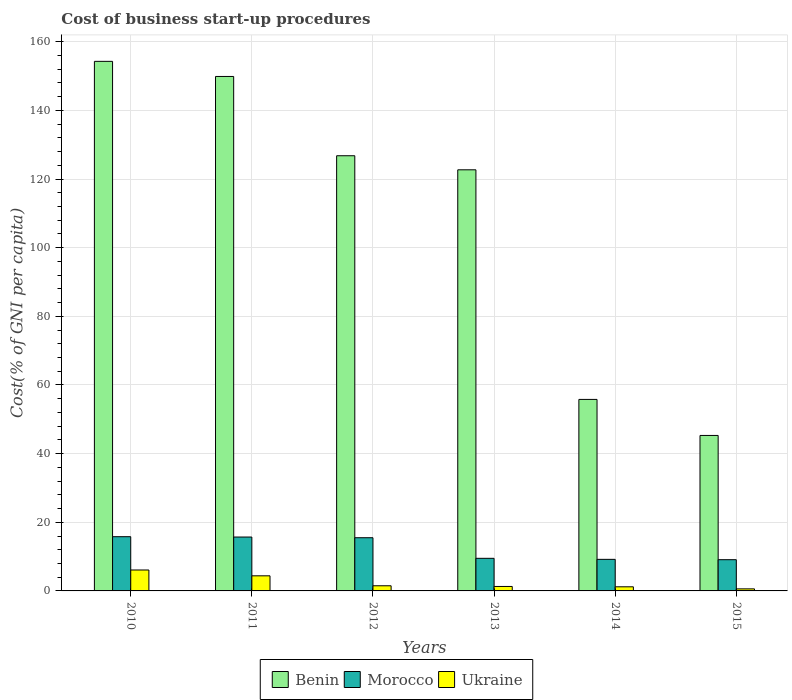Are the number of bars per tick equal to the number of legend labels?
Offer a very short reply. Yes. How many bars are there on the 5th tick from the right?
Provide a short and direct response. 3. What is the label of the 6th group of bars from the left?
Your response must be concise. 2015. In how many cases, is the number of bars for a given year not equal to the number of legend labels?
Offer a terse response. 0. What is the cost of business start-up procedures in Ukraine in 2010?
Ensure brevity in your answer.  6.1. Across all years, what is the maximum cost of business start-up procedures in Benin?
Provide a short and direct response. 154.3. Across all years, what is the minimum cost of business start-up procedures in Morocco?
Give a very brief answer. 9.1. In which year was the cost of business start-up procedures in Benin maximum?
Your response must be concise. 2010. In which year was the cost of business start-up procedures in Morocco minimum?
Provide a succinct answer. 2015. What is the total cost of business start-up procedures in Ukraine in the graph?
Offer a very short reply. 15.1. What is the difference between the cost of business start-up procedures in Benin in 2012 and that in 2014?
Provide a succinct answer. 71. What is the difference between the cost of business start-up procedures in Benin in 2014 and the cost of business start-up procedures in Morocco in 2012?
Your answer should be very brief. 40.3. What is the average cost of business start-up procedures in Benin per year?
Keep it short and to the point. 109.13. In the year 2015, what is the difference between the cost of business start-up procedures in Ukraine and cost of business start-up procedures in Benin?
Provide a short and direct response. -44.7. What is the ratio of the cost of business start-up procedures in Morocco in 2011 to that in 2012?
Provide a succinct answer. 1.01. Is the cost of business start-up procedures in Benin in 2010 less than that in 2012?
Offer a very short reply. No. What is the difference between the highest and the second highest cost of business start-up procedures in Morocco?
Offer a terse response. 0.1. In how many years, is the cost of business start-up procedures in Benin greater than the average cost of business start-up procedures in Benin taken over all years?
Your answer should be very brief. 4. What does the 3rd bar from the left in 2013 represents?
Your answer should be very brief. Ukraine. What does the 2nd bar from the right in 2015 represents?
Provide a succinct answer. Morocco. How many bars are there?
Provide a short and direct response. 18. Where does the legend appear in the graph?
Give a very brief answer. Bottom center. What is the title of the graph?
Give a very brief answer. Cost of business start-up procedures. What is the label or title of the Y-axis?
Your response must be concise. Cost(% of GNI per capita). What is the Cost(% of GNI per capita) of Benin in 2010?
Ensure brevity in your answer.  154.3. What is the Cost(% of GNI per capita) in Ukraine in 2010?
Provide a succinct answer. 6.1. What is the Cost(% of GNI per capita) of Benin in 2011?
Keep it short and to the point. 149.9. What is the Cost(% of GNI per capita) in Ukraine in 2011?
Make the answer very short. 4.4. What is the Cost(% of GNI per capita) of Benin in 2012?
Offer a very short reply. 126.8. What is the Cost(% of GNI per capita) in Ukraine in 2012?
Your response must be concise. 1.5. What is the Cost(% of GNI per capita) of Benin in 2013?
Provide a short and direct response. 122.7. What is the Cost(% of GNI per capita) of Morocco in 2013?
Offer a terse response. 9.5. What is the Cost(% of GNI per capita) in Ukraine in 2013?
Your answer should be compact. 1.3. What is the Cost(% of GNI per capita) in Benin in 2014?
Provide a short and direct response. 55.8. What is the Cost(% of GNI per capita) in Morocco in 2014?
Offer a very short reply. 9.2. What is the Cost(% of GNI per capita) of Ukraine in 2014?
Provide a short and direct response. 1.2. What is the Cost(% of GNI per capita) of Benin in 2015?
Give a very brief answer. 45.3. What is the Cost(% of GNI per capita) of Morocco in 2015?
Ensure brevity in your answer.  9.1. What is the Cost(% of GNI per capita) in Ukraine in 2015?
Your answer should be very brief. 0.6. Across all years, what is the maximum Cost(% of GNI per capita) in Benin?
Offer a terse response. 154.3. Across all years, what is the maximum Cost(% of GNI per capita) of Ukraine?
Provide a succinct answer. 6.1. Across all years, what is the minimum Cost(% of GNI per capita) in Benin?
Your answer should be very brief. 45.3. Across all years, what is the minimum Cost(% of GNI per capita) in Morocco?
Your answer should be very brief. 9.1. Across all years, what is the minimum Cost(% of GNI per capita) in Ukraine?
Offer a very short reply. 0.6. What is the total Cost(% of GNI per capita) of Benin in the graph?
Provide a short and direct response. 654.8. What is the total Cost(% of GNI per capita) of Morocco in the graph?
Offer a terse response. 74.8. What is the total Cost(% of GNI per capita) in Ukraine in the graph?
Provide a short and direct response. 15.1. What is the difference between the Cost(% of GNI per capita) in Benin in 2010 and that in 2011?
Your response must be concise. 4.4. What is the difference between the Cost(% of GNI per capita) of Ukraine in 2010 and that in 2011?
Your response must be concise. 1.7. What is the difference between the Cost(% of GNI per capita) in Benin in 2010 and that in 2012?
Provide a short and direct response. 27.5. What is the difference between the Cost(% of GNI per capita) of Morocco in 2010 and that in 2012?
Provide a short and direct response. 0.3. What is the difference between the Cost(% of GNI per capita) in Ukraine in 2010 and that in 2012?
Offer a terse response. 4.6. What is the difference between the Cost(% of GNI per capita) in Benin in 2010 and that in 2013?
Offer a terse response. 31.6. What is the difference between the Cost(% of GNI per capita) of Benin in 2010 and that in 2014?
Make the answer very short. 98.5. What is the difference between the Cost(% of GNI per capita) in Morocco in 2010 and that in 2014?
Your answer should be compact. 6.6. What is the difference between the Cost(% of GNI per capita) in Ukraine in 2010 and that in 2014?
Your answer should be compact. 4.9. What is the difference between the Cost(% of GNI per capita) of Benin in 2010 and that in 2015?
Offer a very short reply. 109. What is the difference between the Cost(% of GNI per capita) of Benin in 2011 and that in 2012?
Your answer should be very brief. 23.1. What is the difference between the Cost(% of GNI per capita) of Morocco in 2011 and that in 2012?
Ensure brevity in your answer.  0.2. What is the difference between the Cost(% of GNI per capita) of Benin in 2011 and that in 2013?
Provide a succinct answer. 27.2. What is the difference between the Cost(% of GNI per capita) in Benin in 2011 and that in 2014?
Give a very brief answer. 94.1. What is the difference between the Cost(% of GNI per capita) of Benin in 2011 and that in 2015?
Give a very brief answer. 104.6. What is the difference between the Cost(% of GNI per capita) in Morocco in 2011 and that in 2015?
Make the answer very short. 6.6. What is the difference between the Cost(% of GNI per capita) of Ukraine in 2011 and that in 2015?
Ensure brevity in your answer.  3.8. What is the difference between the Cost(% of GNI per capita) in Benin in 2012 and that in 2013?
Offer a terse response. 4.1. What is the difference between the Cost(% of GNI per capita) in Morocco in 2012 and that in 2013?
Your answer should be very brief. 6. What is the difference between the Cost(% of GNI per capita) of Benin in 2012 and that in 2015?
Provide a short and direct response. 81.5. What is the difference between the Cost(% of GNI per capita) of Benin in 2013 and that in 2014?
Your answer should be very brief. 66.9. What is the difference between the Cost(% of GNI per capita) in Morocco in 2013 and that in 2014?
Offer a terse response. 0.3. What is the difference between the Cost(% of GNI per capita) in Benin in 2013 and that in 2015?
Your response must be concise. 77.4. What is the difference between the Cost(% of GNI per capita) of Benin in 2014 and that in 2015?
Ensure brevity in your answer.  10.5. What is the difference between the Cost(% of GNI per capita) in Morocco in 2014 and that in 2015?
Keep it short and to the point. 0.1. What is the difference between the Cost(% of GNI per capita) in Ukraine in 2014 and that in 2015?
Your answer should be compact. 0.6. What is the difference between the Cost(% of GNI per capita) of Benin in 2010 and the Cost(% of GNI per capita) of Morocco in 2011?
Give a very brief answer. 138.6. What is the difference between the Cost(% of GNI per capita) of Benin in 2010 and the Cost(% of GNI per capita) of Ukraine in 2011?
Ensure brevity in your answer.  149.9. What is the difference between the Cost(% of GNI per capita) in Morocco in 2010 and the Cost(% of GNI per capita) in Ukraine in 2011?
Offer a very short reply. 11.4. What is the difference between the Cost(% of GNI per capita) in Benin in 2010 and the Cost(% of GNI per capita) in Morocco in 2012?
Give a very brief answer. 138.8. What is the difference between the Cost(% of GNI per capita) of Benin in 2010 and the Cost(% of GNI per capita) of Ukraine in 2012?
Your answer should be very brief. 152.8. What is the difference between the Cost(% of GNI per capita) of Benin in 2010 and the Cost(% of GNI per capita) of Morocco in 2013?
Offer a very short reply. 144.8. What is the difference between the Cost(% of GNI per capita) in Benin in 2010 and the Cost(% of GNI per capita) in Ukraine in 2013?
Your response must be concise. 153. What is the difference between the Cost(% of GNI per capita) in Morocco in 2010 and the Cost(% of GNI per capita) in Ukraine in 2013?
Provide a succinct answer. 14.5. What is the difference between the Cost(% of GNI per capita) of Benin in 2010 and the Cost(% of GNI per capita) of Morocco in 2014?
Make the answer very short. 145.1. What is the difference between the Cost(% of GNI per capita) in Benin in 2010 and the Cost(% of GNI per capita) in Ukraine in 2014?
Your answer should be compact. 153.1. What is the difference between the Cost(% of GNI per capita) in Morocco in 2010 and the Cost(% of GNI per capita) in Ukraine in 2014?
Give a very brief answer. 14.6. What is the difference between the Cost(% of GNI per capita) of Benin in 2010 and the Cost(% of GNI per capita) of Morocco in 2015?
Make the answer very short. 145.2. What is the difference between the Cost(% of GNI per capita) in Benin in 2010 and the Cost(% of GNI per capita) in Ukraine in 2015?
Your answer should be very brief. 153.7. What is the difference between the Cost(% of GNI per capita) of Benin in 2011 and the Cost(% of GNI per capita) of Morocco in 2012?
Ensure brevity in your answer.  134.4. What is the difference between the Cost(% of GNI per capita) of Benin in 2011 and the Cost(% of GNI per capita) of Ukraine in 2012?
Give a very brief answer. 148.4. What is the difference between the Cost(% of GNI per capita) in Benin in 2011 and the Cost(% of GNI per capita) in Morocco in 2013?
Your answer should be very brief. 140.4. What is the difference between the Cost(% of GNI per capita) in Benin in 2011 and the Cost(% of GNI per capita) in Ukraine in 2013?
Your answer should be compact. 148.6. What is the difference between the Cost(% of GNI per capita) of Morocco in 2011 and the Cost(% of GNI per capita) of Ukraine in 2013?
Keep it short and to the point. 14.4. What is the difference between the Cost(% of GNI per capita) in Benin in 2011 and the Cost(% of GNI per capita) in Morocco in 2014?
Your response must be concise. 140.7. What is the difference between the Cost(% of GNI per capita) in Benin in 2011 and the Cost(% of GNI per capita) in Ukraine in 2014?
Provide a succinct answer. 148.7. What is the difference between the Cost(% of GNI per capita) of Morocco in 2011 and the Cost(% of GNI per capita) of Ukraine in 2014?
Your answer should be very brief. 14.5. What is the difference between the Cost(% of GNI per capita) of Benin in 2011 and the Cost(% of GNI per capita) of Morocco in 2015?
Your response must be concise. 140.8. What is the difference between the Cost(% of GNI per capita) in Benin in 2011 and the Cost(% of GNI per capita) in Ukraine in 2015?
Offer a very short reply. 149.3. What is the difference between the Cost(% of GNI per capita) of Benin in 2012 and the Cost(% of GNI per capita) of Morocco in 2013?
Offer a terse response. 117.3. What is the difference between the Cost(% of GNI per capita) in Benin in 2012 and the Cost(% of GNI per capita) in Ukraine in 2013?
Make the answer very short. 125.5. What is the difference between the Cost(% of GNI per capita) of Benin in 2012 and the Cost(% of GNI per capita) of Morocco in 2014?
Your answer should be very brief. 117.6. What is the difference between the Cost(% of GNI per capita) in Benin in 2012 and the Cost(% of GNI per capita) in Ukraine in 2014?
Provide a short and direct response. 125.6. What is the difference between the Cost(% of GNI per capita) in Benin in 2012 and the Cost(% of GNI per capita) in Morocco in 2015?
Offer a very short reply. 117.7. What is the difference between the Cost(% of GNI per capita) in Benin in 2012 and the Cost(% of GNI per capita) in Ukraine in 2015?
Give a very brief answer. 126.2. What is the difference between the Cost(% of GNI per capita) in Morocco in 2012 and the Cost(% of GNI per capita) in Ukraine in 2015?
Your answer should be very brief. 14.9. What is the difference between the Cost(% of GNI per capita) in Benin in 2013 and the Cost(% of GNI per capita) in Morocco in 2014?
Make the answer very short. 113.5. What is the difference between the Cost(% of GNI per capita) of Benin in 2013 and the Cost(% of GNI per capita) of Ukraine in 2014?
Provide a succinct answer. 121.5. What is the difference between the Cost(% of GNI per capita) in Morocco in 2013 and the Cost(% of GNI per capita) in Ukraine in 2014?
Ensure brevity in your answer.  8.3. What is the difference between the Cost(% of GNI per capita) of Benin in 2013 and the Cost(% of GNI per capita) of Morocco in 2015?
Offer a very short reply. 113.6. What is the difference between the Cost(% of GNI per capita) of Benin in 2013 and the Cost(% of GNI per capita) of Ukraine in 2015?
Your answer should be compact. 122.1. What is the difference between the Cost(% of GNI per capita) in Benin in 2014 and the Cost(% of GNI per capita) in Morocco in 2015?
Your answer should be compact. 46.7. What is the difference between the Cost(% of GNI per capita) of Benin in 2014 and the Cost(% of GNI per capita) of Ukraine in 2015?
Offer a terse response. 55.2. What is the average Cost(% of GNI per capita) in Benin per year?
Your answer should be very brief. 109.13. What is the average Cost(% of GNI per capita) of Morocco per year?
Your answer should be compact. 12.47. What is the average Cost(% of GNI per capita) of Ukraine per year?
Your answer should be very brief. 2.52. In the year 2010, what is the difference between the Cost(% of GNI per capita) of Benin and Cost(% of GNI per capita) of Morocco?
Make the answer very short. 138.5. In the year 2010, what is the difference between the Cost(% of GNI per capita) in Benin and Cost(% of GNI per capita) in Ukraine?
Provide a succinct answer. 148.2. In the year 2011, what is the difference between the Cost(% of GNI per capita) in Benin and Cost(% of GNI per capita) in Morocco?
Provide a short and direct response. 134.2. In the year 2011, what is the difference between the Cost(% of GNI per capita) in Benin and Cost(% of GNI per capita) in Ukraine?
Give a very brief answer. 145.5. In the year 2011, what is the difference between the Cost(% of GNI per capita) of Morocco and Cost(% of GNI per capita) of Ukraine?
Ensure brevity in your answer.  11.3. In the year 2012, what is the difference between the Cost(% of GNI per capita) of Benin and Cost(% of GNI per capita) of Morocco?
Your answer should be very brief. 111.3. In the year 2012, what is the difference between the Cost(% of GNI per capita) in Benin and Cost(% of GNI per capita) in Ukraine?
Provide a succinct answer. 125.3. In the year 2013, what is the difference between the Cost(% of GNI per capita) in Benin and Cost(% of GNI per capita) in Morocco?
Provide a short and direct response. 113.2. In the year 2013, what is the difference between the Cost(% of GNI per capita) in Benin and Cost(% of GNI per capita) in Ukraine?
Your answer should be compact. 121.4. In the year 2014, what is the difference between the Cost(% of GNI per capita) of Benin and Cost(% of GNI per capita) of Morocco?
Provide a succinct answer. 46.6. In the year 2014, what is the difference between the Cost(% of GNI per capita) of Benin and Cost(% of GNI per capita) of Ukraine?
Keep it short and to the point. 54.6. In the year 2014, what is the difference between the Cost(% of GNI per capita) of Morocco and Cost(% of GNI per capita) of Ukraine?
Provide a short and direct response. 8. In the year 2015, what is the difference between the Cost(% of GNI per capita) in Benin and Cost(% of GNI per capita) in Morocco?
Make the answer very short. 36.2. In the year 2015, what is the difference between the Cost(% of GNI per capita) in Benin and Cost(% of GNI per capita) in Ukraine?
Make the answer very short. 44.7. What is the ratio of the Cost(% of GNI per capita) of Benin in 2010 to that in 2011?
Make the answer very short. 1.03. What is the ratio of the Cost(% of GNI per capita) in Morocco in 2010 to that in 2011?
Provide a succinct answer. 1.01. What is the ratio of the Cost(% of GNI per capita) in Ukraine in 2010 to that in 2011?
Your response must be concise. 1.39. What is the ratio of the Cost(% of GNI per capita) of Benin in 2010 to that in 2012?
Keep it short and to the point. 1.22. What is the ratio of the Cost(% of GNI per capita) of Morocco in 2010 to that in 2012?
Provide a short and direct response. 1.02. What is the ratio of the Cost(% of GNI per capita) in Ukraine in 2010 to that in 2012?
Your answer should be very brief. 4.07. What is the ratio of the Cost(% of GNI per capita) in Benin in 2010 to that in 2013?
Give a very brief answer. 1.26. What is the ratio of the Cost(% of GNI per capita) in Morocco in 2010 to that in 2013?
Provide a short and direct response. 1.66. What is the ratio of the Cost(% of GNI per capita) of Ukraine in 2010 to that in 2013?
Provide a short and direct response. 4.69. What is the ratio of the Cost(% of GNI per capita) in Benin in 2010 to that in 2014?
Make the answer very short. 2.77. What is the ratio of the Cost(% of GNI per capita) of Morocco in 2010 to that in 2014?
Ensure brevity in your answer.  1.72. What is the ratio of the Cost(% of GNI per capita) of Ukraine in 2010 to that in 2014?
Provide a short and direct response. 5.08. What is the ratio of the Cost(% of GNI per capita) of Benin in 2010 to that in 2015?
Provide a short and direct response. 3.41. What is the ratio of the Cost(% of GNI per capita) of Morocco in 2010 to that in 2015?
Make the answer very short. 1.74. What is the ratio of the Cost(% of GNI per capita) of Ukraine in 2010 to that in 2015?
Provide a short and direct response. 10.17. What is the ratio of the Cost(% of GNI per capita) of Benin in 2011 to that in 2012?
Provide a short and direct response. 1.18. What is the ratio of the Cost(% of GNI per capita) in Morocco in 2011 to that in 2012?
Your answer should be very brief. 1.01. What is the ratio of the Cost(% of GNI per capita) in Ukraine in 2011 to that in 2012?
Your answer should be very brief. 2.93. What is the ratio of the Cost(% of GNI per capita) of Benin in 2011 to that in 2013?
Your response must be concise. 1.22. What is the ratio of the Cost(% of GNI per capita) of Morocco in 2011 to that in 2013?
Provide a succinct answer. 1.65. What is the ratio of the Cost(% of GNI per capita) in Ukraine in 2011 to that in 2013?
Offer a very short reply. 3.38. What is the ratio of the Cost(% of GNI per capita) in Benin in 2011 to that in 2014?
Provide a short and direct response. 2.69. What is the ratio of the Cost(% of GNI per capita) in Morocco in 2011 to that in 2014?
Give a very brief answer. 1.71. What is the ratio of the Cost(% of GNI per capita) in Ukraine in 2011 to that in 2014?
Ensure brevity in your answer.  3.67. What is the ratio of the Cost(% of GNI per capita) of Benin in 2011 to that in 2015?
Your response must be concise. 3.31. What is the ratio of the Cost(% of GNI per capita) of Morocco in 2011 to that in 2015?
Offer a terse response. 1.73. What is the ratio of the Cost(% of GNI per capita) in Ukraine in 2011 to that in 2015?
Ensure brevity in your answer.  7.33. What is the ratio of the Cost(% of GNI per capita) of Benin in 2012 to that in 2013?
Provide a short and direct response. 1.03. What is the ratio of the Cost(% of GNI per capita) in Morocco in 2012 to that in 2013?
Your answer should be compact. 1.63. What is the ratio of the Cost(% of GNI per capita) in Ukraine in 2012 to that in 2013?
Keep it short and to the point. 1.15. What is the ratio of the Cost(% of GNI per capita) of Benin in 2012 to that in 2014?
Provide a succinct answer. 2.27. What is the ratio of the Cost(% of GNI per capita) in Morocco in 2012 to that in 2014?
Offer a very short reply. 1.68. What is the ratio of the Cost(% of GNI per capita) of Benin in 2012 to that in 2015?
Ensure brevity in your answer.  2.8. What is the ratio of the Cost(% of GNI per capita) in Morocco in 2012 to that in 2015?
Your answer should be very brief. 1.7. What is the ratio of the Cost(% of GNI per capita) in Ukraine in 2012 to that in 2015?
Offer a terse response. 2.5. What is the ratio of the Cost(% of GNI per capita) of Benin in 2013 to that in 2014?
Provide a succinct answer. 2.2. What is the ratio of the Cost(% of GNI per capita) in Morocco in 2013 to that in 2014?
Offer a very short reply. 1.03. What is the ratio of the Cost(% of GNI per capita) of Ukraine in 2013 to that in 2014?
Make the answer very short. 1.08. What is the ratio of the Cost(% of GNI per capita) of Benin in 2013 to that in 2015?
Make the answer very short. 2.71. What is the ratio of the Cost(% of GNI per capita) in Morocco in 2013 to that in 2015?
Offer a very short reply. 1.04. What is the ratio of the Cost(% of GNI per capita) in Ukraine in 2013 to that in 2015?
Give a very brief answer. 2.17. What is the ratio of the Cost(% of GNI per capita) of Benin in 2014 to that in 2015?
Offer a very short reply. 1.23. What is the ratio of the Cost(% of GNI per capita) in Morocco in 2014 to that in 2015?
Make the answer very short. 1.01. What is the ratio of the Cost(% of GNI per capita) in Ukraine in 2014 to that in 2015?
Your answer should be compact. 2. What is the difference between the highest and the lowest Cost(% of GNI per capita) in Benin?
Your answer should be compact. 109. What is the difference between the highest and the lowest Cost(% of GNI per capita) in Ukraine?
Give a very brief answer. 5.5. 